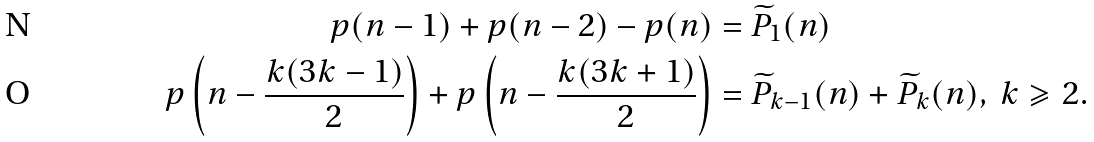Convert formula to latex. <formula><loc_0><loc_0><loc_500><loc_500>p ( n - 1 ) + p ( n - 2 ) - p ( n ) & = \widetilde { P } _ { 1 } ( n ) \\ p \left ( n - \frac { k ( 3 k - 1 ) } { 2 } \right ) + p \left ( n - \frac { k ( 3 k + 1 ) } { 2 } \right ) & = \widetilde { P } _ { k - 1 } ( n ) + \widetilde { P } _ { k } ( n ) , \ k \geqslant 2 .</formula> 